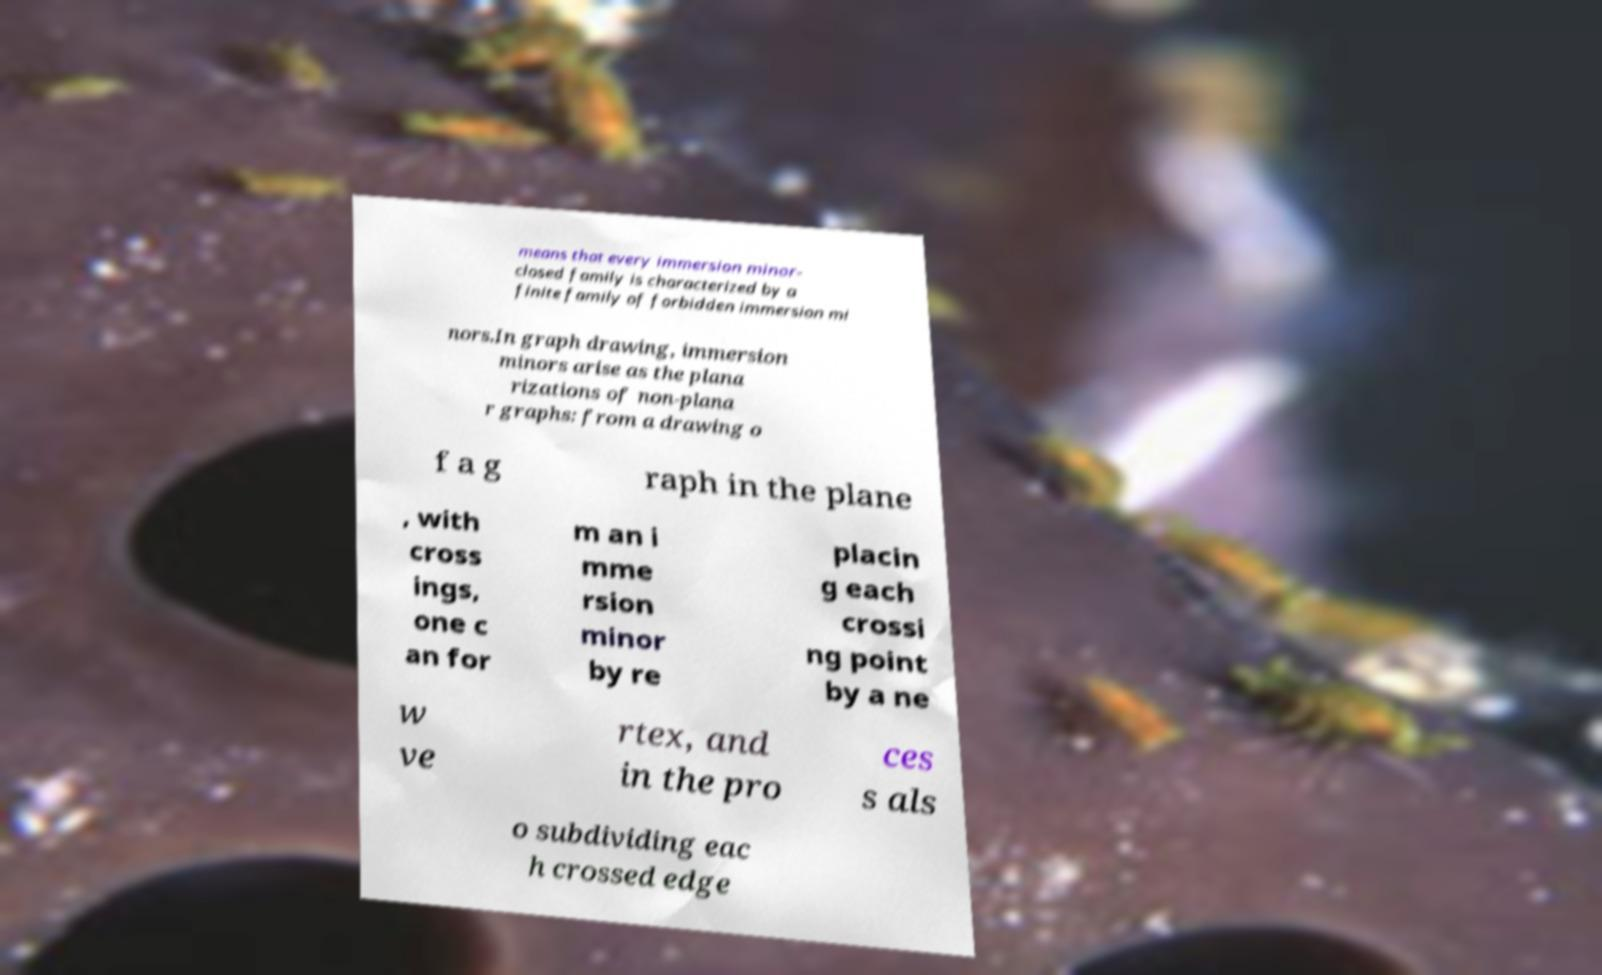There's text embedded in this image that I need extracted. Can you transcribe it verbatim? means that every immersion minor- closed family is characterized by a finite family of forbidden immersion mi nors.In graph drawing, immersion minors arise as the plana rizations of non-plana r graphs: from a drawing o f a g raph in the plane , with cross ings, one c an for m an i mme rsion minor by re placin g each crossi ng point by a ne w ve rtex, and in the pro ces s als o subdividing eac h crossed edge 